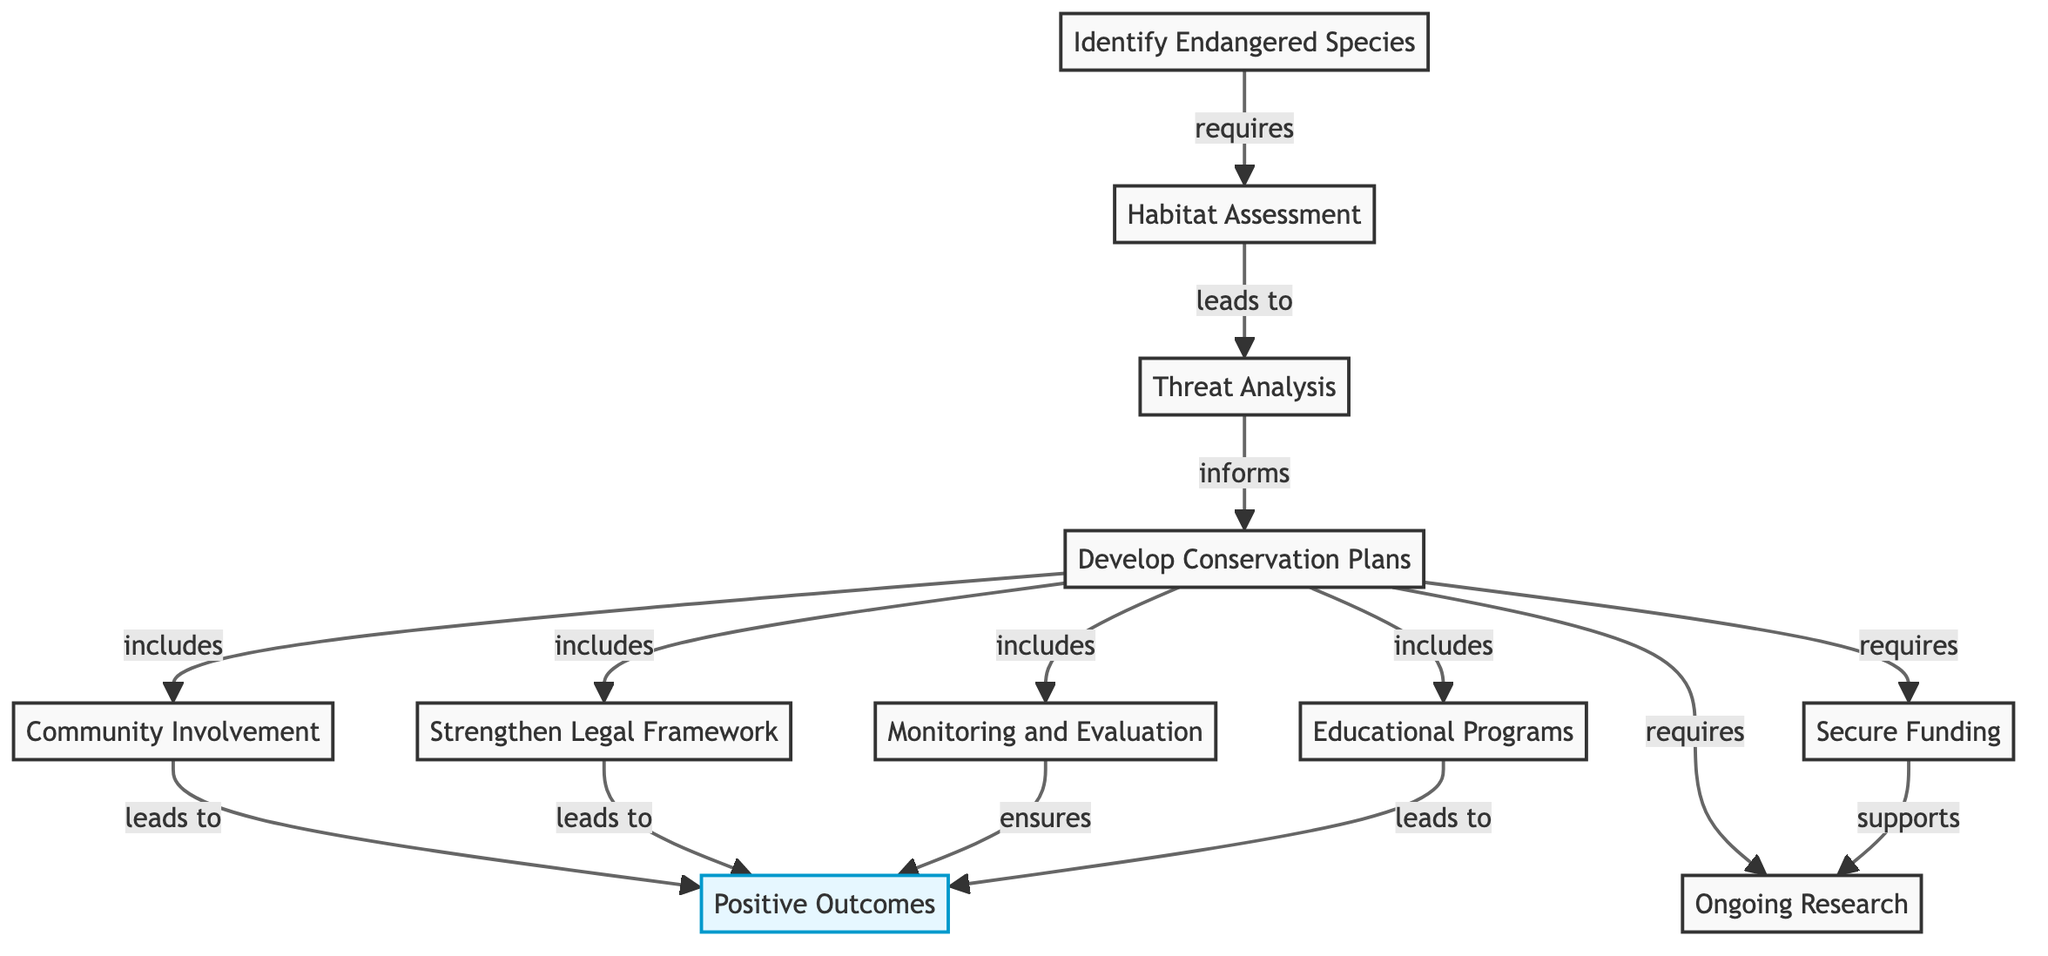What is the first step in the conservation strategy flowchart? The flowchart starts with the node "Identify Endangered Species," indicating that the first action is to identify which species are threatened.
Answer: Identify Endangered Species How many framework components are included in the conservation plans? The conservation plans include four components: community involvement, legal framework, monitoring, and educational programs. Therefore, the total number of components is four.
Answer: Four Which two nodes lead to positive outcomes? The nodes "Community Involvement" and "Legal Framework" both directly lead to the node "Positive Outcomes." This indicates that both community engagement and legal support contribute to successful conservation efforts.
Answer: Community Involvement and Legal Framework What must be conducted after identifying endangered species? Following the identification of endangered species, a "Habitat Assessment" must be conducted to evaluate the environmental needs of the species identified.
Answer: Habitat Assessment Which node requires securing funding as a part of the conservation plans? Within the section detailing conservation plans, the node "Funding" is specifically mentioned, indicating that financial resources are required to support the development and implementation of these plans.
Answer: Funding What supports ongoing research according to the flowchart? The flowchart indicates that "Funding" directly supports "Ongoing Research," indicating that financial backing is essential for conducting continuous research in conservation efforts.
Answer: Funding How many total actions must be taken to achieve positive outcomes? To achieve positive outcomes, three actions must be engaged: community involvement, legal framework, and monitoring, according to the flowchart. Thus, the total actions linked to positive outcomes is three.
Answer: Three Which node indicates the need for an assessment of threats to the endangered species? The flowchart describes "Threat Analysis" as the node that follows after "Habitat Assessment," indicating that an assessment of threats is necessary as the next step in the conservation strategy.
Answer: Threat Analysis What is required for the conservation plans in addition to community involvement and monitoring? The conservation plans require "Research" in addition to community involvement and monitoring, showcasing the necessity of gaining knowledge and data to inform these plans adequately.
Answer: Research 